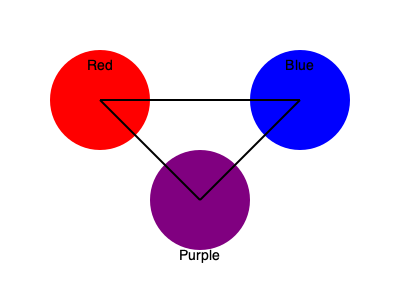As an artist exploring color theory, you're experimenting with mixing primary colors. If you combine equal parts of red and blue, what secondary color will you create? How would you describe the resulting hue in terms of its position on the color wheel? To answer this question, let's follow these steps:

1. Identify the primary colors involved:
   - Red and Blue are both primary colors.

2. Understand color mixing principles:
   - When two primary colors are mixed in equal parts, they create a secondary color.

3. Determine the resulting secondary color:
   - Red + Blue = Purple

4. Analyze the color wheel:
   - On a standard color wheel, purple is located between red and blue.
   - It sits opposite to yellow, which is the third primary color.

5. Describe the hue's position:
   - Purple is a secondary color that appears exactly halfway between red and blue on the color wheel.
   - It is created by an equal mixture of these two primary colors.

6. Consider the artistic implications:
   - As an artist, understanding this color relationship allows for creating balanced color schemes and harmonious compositions.
   - The resulting purple can be adjusted by varying the ratios of red and blue, leading to warmer or cooler purple hues.
Answer: Purple; midway between red and blue on the color wheel. 